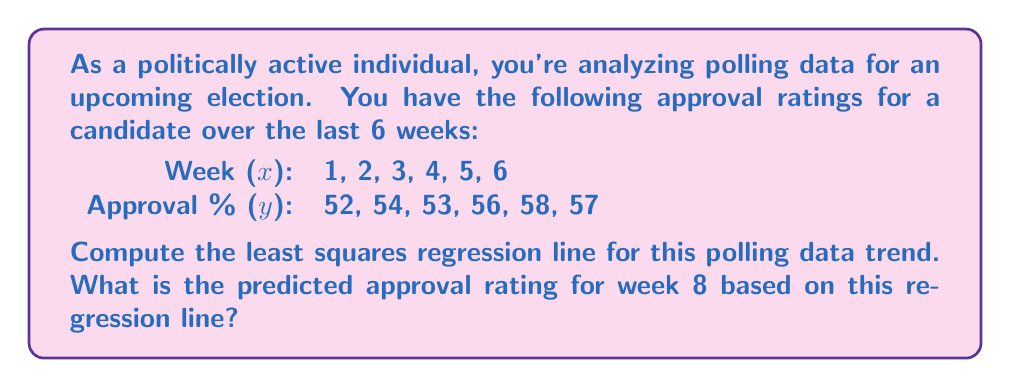Solve this math problem. To find the least squares regression line, we need to calculate the slope (m) and y-intercept (b) of the line y = mx + b.

Step 1: Calculate the means of x and y
$\bar{x} = \frac{1+2+3+4+5+6}{6} = 3.5$
$\bar{y} = \frac{52+54+53+56+58+57}{6} = 55$

Step 2: Calculate Sxx, Syy, and Sxy
$S_{xx} = \sum(x_i - \bar{x})^2 = (1-3.5)^2 + (2-3.5)^2 + ... + (6-3.5)^2 = 17.5$
$S_{yy} = \sum(y_i - \bar{y})^2 = (52-55)^2 + (54-55)^2 + ... + (57-55)^2 = 38$
$S_{xy} = \sum(x_i - \bar{x})(y_i - \bar{y}) = (1-3.5)(52-55) + ... + (6-3.5)(57-55) = 23$

Step 3: Calculate the slope m
$m = \frac{S_{xy}}{S_{xx}} = \frac{23}{17.5} = 1.314$

Step 4: Calculate the y-intercept b
$b = \bar{y} - m\bar{x} = 55 - 1.314(3.5) = 50.4$

The least squares regression line is:
$y = 1.314x + 50.4$

Step 5: Predict the approval rating for week 8
$y = 1.314(8) + 50.4 = 60.912$
Answer: The least squares regression line is $y = 1.314x + 50.4$, and the predicted approval rating for week 8 is 60.912%. 